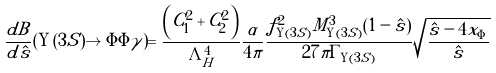Convert formula to latex. <formula><loc_0><loc_0><loc_500><loc_500>\frac { d B } { d \hat { s } } ( \Upsilon ( 3 S ) \to \Phi \Phi \gamma ) = \frac { \left ( C _ { 1 } ^ { 2 } + C _ { 2 } ^ { 2 } \right ) } { \Lambda _ { H } ^ { 4 } } \frac { \alpha } { 4 \pi } \frac { f _ { \Upsilon ( 3 S ) } ^ { 2 } M _ { \Upsilon ( 3 S ) } ^ { 3 } ( 1 - \hat { s } ) } { 2 7 \pi \Gamma _ { \Upsilon ( 3 S ) } } \sqrt { \frac { \hat { s } - 4 x _ { \Phi } } { \hat { s } } }</formula> 